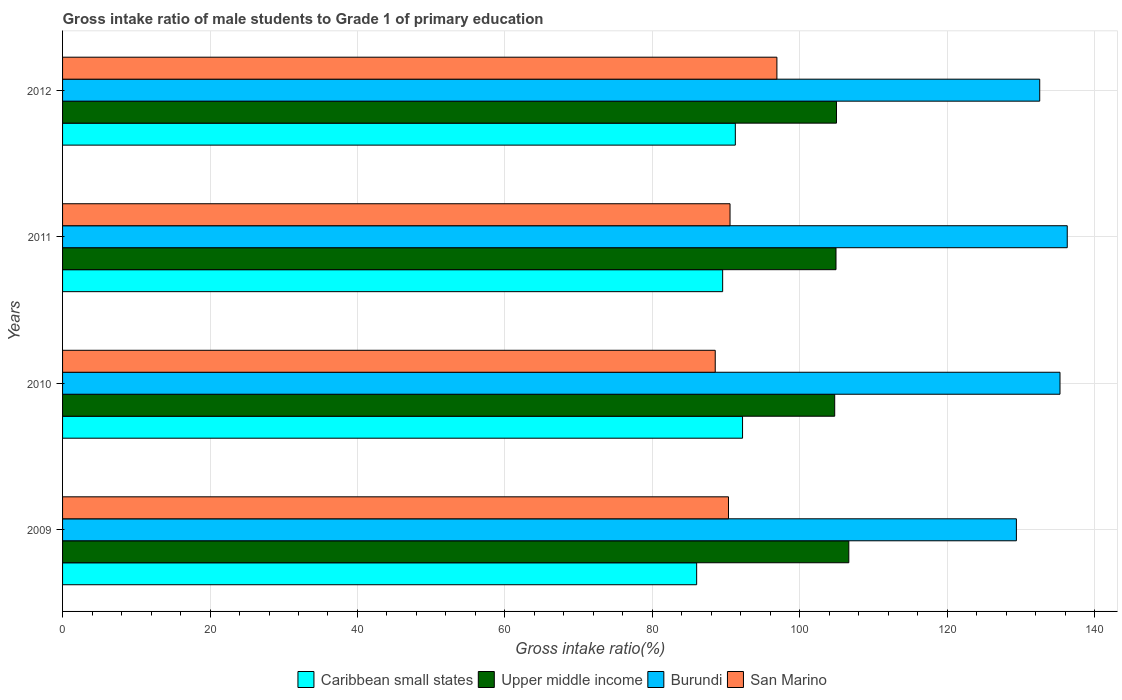Are the number of bars on each tick of the Y-axis equal?
Your response must be concise. Yes. How many bars are there on the 1st tick from the top?
Your answer should be compact. 4. What is the label of the 3rd group of bars from the top?
Offer a terse response. 2010. In how many cases, is the number of bars for a given year not equal to the number of legend labels?
Provide a short and direct response. 0. What is the gross intake ratio in San Marino in 2011?
Your answer should be very brief. 90.53. Across all years, what is the maximum gross intake ratio in San Marino?
Ensure brevity in your answer.  96.89. Across all years, what is the minimum gross intake ratio in San Marino?
Your answer should be very brief. 88.52. In which year was the gross intake ratio in Burundi maximum?
Provide a succinct answer. 2011. What is the total gross intake ratio in San Marino in the graph?
Offer a very short reply. 366.27. What is the difference between the gross intake ratio in San Marino in 2009 and that in 2011?
Ensure brevity in your answer.  -0.21. What is the difference between the gross intake ratio in San Marino in 2010 and the gross intake ratio in Caribbean small states in 2009?
Your response must be concise. 2.52. What is the average gross intake ratio in Burundi per year?
Provide a succinct answer. 133.37. In the year 2010, what is the difference between the gross intake ratio in San Marino and gross intake ratio in Caribbean small states?
Offer a very short reply. -3.71. What is the ratio of the gross intake ratio in Upper middle income in 2010 to that in 2011?
Your answer should be very brief. 1. Is the difference between the gross intake ratio in San Marino in 2011 and 2012 greater than the difference between the gross intake ratio in Caribbean small states in 2011 and 2012?
Make the answer very short. No. What is the difference between the highest and the second highest gross intake ratio in Upper middle income?
Keep it short and to the point. 1.67. What is the difference between the highest and the lowest gross intake ratio in Caribbean small states?
Keep it short and to the point. 6.23. In how many years, is the gross intake ratio in Upper middle income greater than the average gross intake ratio in Upper middle income taken over all years?
Provide a succinct answer. 1. Is the sum of the gross intake ratio in Upper middle income in 2010 and 2011 greater than the maximum gross intake ratio in San Marino across all years?
Make the answer very short. Yes. What does the 3rd bar from the top in 2012 represents?
Ensure brevity in your answer.  Upper middle income. What does the 1st bar from the bottom in 2011 represents?
Offer a very short reply. Caribbean small states. How many years are there in the graph?
Provide a short and direct response. 4. Where does the legend appear in the graph?
Make the answer very short. Bottom center. How are the legend labels stacked?
Offer a terse response. Horizontal. What is the title of the graph?
Your answer should be compact. Gross intake ratio of male students to Grade 1 of primary education. What is the label or title of the X-axis?
Your response must be concise. Gross intake ratio(%). What is the Gross intake ratio(%) of Caribbean small states in 2009?
Provide a short and direct response. 86. What is the Gross intake ratio(%) in Upper middle income in 2009?
Make the answer very short. 106.64. What is the Gross intake ratio(%) in Burundi in 2009?
Offer a terse response. 129.37. What is the Gross intake ratio(%) in San Marino in 2009?
Provide a short and direct response. 90.32. What is the Gross intake ratio(%) in Caribbean small states in 2010?
Provide a short and direct response. 92.23. What is the Gross intake ratio(%) of Upper middle income in 2010?
Make the answer very short. 104.73. What is the Gross intake ratio(%) of Burundi in 2010?
Ensure brevity in your answer.  135.29. What is the Gross intake ratio(%) in San Marino in 2010?
Ensure brevity in your answer.  88.52. What is the Gross intake ratio(%) in Caribbean small states in 2011?
Offer a very short reply. 89.53. What is the Gross intake ratio(%) in Upper middle income in 2011?
Your answer should be very brief. 104.91. What is the Gross intake ratio(%) of Burundi in 2011?
Keep it short and to the point. 136.27. What is the Gross intake ratio(%) in San Marino in 2011?
Provide a short and direct response. 90.53. What is the Gross intake ratio(%) of Caribbean small states in 2012?
Your answer should be compact. 91.25. What is the Gross intake ratio(%) in Upper middle income in 2012?
Keep it short and to the point. 104.97. What is the Gross intake ratio(%) in Burundi in 2012?
Your answer should be very brief. 132.54. What is the Gross intake ratio(%) in San Marino in 2012?
Offer a terse response. 96.89. Across all years, what is the maximum Gross intake ratio(%) of Caribbean small states?
Provide a succinct answer. 92.23. Across all years, what is the maximum Gross intake ratio(%) in Upper middle income?
Your answer should be very brief. 106.64. Across all years, what is the maximum Gross intake ratio(%) in Burundi?
Your answer should be compact. 136.27. Across all years, what is the maximum Gross intake ratio(%) of San Marino?
Your answer should be compact. 96.89. Across all years, what is the minimum Gross intake ratio(%) of Caribbean small states?
Keep it short and to the point. 86. Across all years, what is the minimum Gross intake ratio(%) of Upper middle income?
Offer a terse response. 104.73. Across all years, what is the minimum Gross intake ratio(%) in Burundi?
Ensure brevity in your answer.  129.37. Across all years, what is the minimum Gross intake ratio(%) in San Marino?
Keep it short and to the point. 88.52. What is the total Gross intake ratio(%) of Caribbean small states in the graph?
Offer a terse response. 359.02. What is the total Gross intake ratio(%) of Upper middle income in the graph?
Offer a very short reply. 421.25. What is the total Gross intake ratio(%) of Burundi in the graph?
Provide a succinct answer. 533.47. What is the total Gross intake ratio(%) of San Marino in the graph?
Keep it short and to the point. 366.27. What is the difference between the Gross intake ratio(%) of Caribbean small states in 2009 and that in 2010?
Provide a succinct answer. -6.23. What is the difference between the Gross intake ratio(%) of Upper middle income in 2009 and that in 2010?
Provide a succinct answer. 1.92. What is the difference between the Gross intake ratio(%) in Burundi in 2009 and that in 2010?
Offer a very short reply. -5.92. What is the difference between the Gross intake ratio(%) of San Marino in 2009 and that in 2010?
Keep it short and to the point. 1.8. What is the difference between the Gross intake ratio(%) in Caribbean small states in 2009 and that in 2011?
Keep it short and to the point. -3.53. What is the difference between the Gross intake ratio(%) of Upper middle income in 2009 and that in 2011?
Your answer should be compact. 1.74. What is the difference between the Gross intake ratio(%) of Burundi in 2009 and that in 2011?
Your answer should be compact. -6.9. What is the difference between the Gross intake ratio(%) of San Marino in 2009 and that in 2011?
Your response must be concise. -0.21. What is the difference between the Gross intake ratio(%) in Caribbean small states in 2009 and that in 2012?
Make the answer very short. -5.25. What is the difference between the Gross intake ratio(%) in Upper middle income in 2009 and that in 2012?
Make the answer very short. 1.67. What is the difference between the Gross intake ratio(%) in Burundi in 2009 and that in 2012?
Your answer should be compact. -3.16. What is the difference between the Gross intake ratio(%) in San Marino in 2009 and that in 2012?
Give a very brief answer. -6.57. What is the difference between the Gross intake ratio(%) of Caribbean small states in 2010 and that in 2011?
Offer a terse response. 2.7. What is the difference between the Gross intake ratio(%) in Upper middle income in 2010 and that in 2011?
Provide a succinct answer. -0.18. What is the difference between the Gross intake ratio(%) in Burundi in 2010 and that in 2011?
Give a very brief answer. -0.98. What is the difference between the Gross intake ratio(%) of San Marino in 2010 and that in 2011?
Your answer should be very brief. -2.01. What is the difference between the Gross intake ratio(%) in Caribbean small states in 2010 and that in 2012?
Offer a terse response. 0.98. What is the difference between the Gross intake ratio(%) of Upper middle income in 2010 and that in 2012?
Give a very brief answer. -0.24. What is the difference between the Gross intake ratio(%) in Burundi in 2010 and that in 2012?
Provide a succinct answer. 2.75. What is the difference between the Gross intake ratio(%) of San Marino in 2010 and that in 2012?
Ensure brevity in your answer.  -8.37. What is the difference between the Gross intake ratio(%) of Caribbean small states in 2011 and that in 2012?
Your answer should be compact. -1.72. What is the difference between the Gross intake ratio(%) in Upper middle income in 2011 and that in 2012?
Your response must be concise. -0.07. What is the difference between the Gross intake ratio(%) in Burundi in 2011 and that in 2012?
Give a very brief answer. 3.74. What is the difference between the Gross intake ratio(%) of San Marino in 2011 and that in 2012?
Offer a terse response. -6.36. What is the difference between the Gross intake ratio(%) of Caribbean small states in 2009 and the Gross intake ratio(%) of Upper middle income in 2010?
Provide a short and direct response. -18.72. What is the difference between the Gross intake ratio(%) in Caribbean small states in 2009 and the Gross intake ratio(%) in Burundi in 2010?
Provide a short and direct response. -49.28. What is the difference between the Gross intake ratio(%) of Caribbean small states in 2009 and the Gross intake ratio(%) of San Marino in 2010?
Your answer should be compact. -2.52. What is the difference between the Gross intake ratio(%) of Upper middle income in 2009 and the Gross intake ratio(%) of Burundi in 2010?
Your answer should be very brief. -28.64. What is the difference between the Gross intake ratio(%) of Upper middle income in 2009 and the Gross intake ratio(%) of San Marino in 2010?
Offer a terse response. 18.12. What is the difference between the Gross intake ratio(%) of Burundi in 2009 and the Gross intake ratio(%) of San Marino in 2010?
Make the answer very short. 40.85. What is the difference between the Gross intake ratio(%) in Caribbean small states in 2009 and the Gross intake ratio(%) in Upper middle income in 2011?
Offer a very short reply. -18.9. What is the difference between the Gross intake ratio(%) of Caribbean small states in 2009 and the Gross intake ratio(%) of Burundi in 2011?
Your response must be concise. -50.27. What is the difference between the Gross intake ratio(%) in Caribbean small states in 2009 and the Gross intake ratio(%) in San Marino in 2011?
Your response must be concise. -4.53. What is the difference between the Gross intake ratio(%) in Upper middle income in 2009 and the Gross intake ratio(%) in Burundi in 2011?
Provide a succinct answer. -29.63. What is the difference between the Gross intake ratio(%) of Upper middle income in 2009 and the Gross intake ratio(%) of San Marino in 2011?
Your response must be concise. 16.11. What is the difference between the Gross intake ratio(%) of Burundi in 2009 and the Gross intake ratio(%) of San Marino in 2011?
Your response must be concise. 38.84. What is the difference between the Gross intake ratio(%) in Caribbean small states in 2009 and the Gross intake ratio(%) in Upper middle income in 2012?
Provide a succinct answer. -18.97. What is the difference between the Gross intake ratio(%) in Caribbean small states in 2009 and the Gross intake ratio(%) in Burundi in 2012?
Your answer should be compact. -46.53. What is the difference between the Gross intake ratio(%) of Caribbean small states in 2009 and the Gross intake ratio(%) of San Marino in 2012?
Provide a succinct answer. -10.89. What is the difference between the Gross intake ratio(%) in Upper middle income in 2009 and the Gross intake ratio(%) in Burundi in 2012?
Your answer should be compact. -25.89. What is the difference between the Gross intake ratio(%) in Upper middle income in 2009 and the Gross intake ratio(%) in San Marino in 2012?
Offer a very short reply. 9.75. What is the difference between the Gross intake ratio(%) in Burundi in 2009 and the Gross intake ratio(%) in San Marino in 2012?
Your response must be concise. 32.48. What is the difference between the Gross intake ratio(%) in Caribbean small states in 2010 and the Gross intake ratio(%) in Upper middle income in 2011?
Keep it short and to the point. -12.68. What is the difference between the Gross intake ratio(%) of Caribbean small states in 2010 and the Gross intake ratio(%) of Burundi in 2011?
Your answer should be compact. -44.04. What is the difference between the Gross intake ratio(%) in Caribbean small states in 2010 and the Gross intake ratio(%) in San Marino in 2011?
Keep it short and to the point. 1.7. What is the difference between the Gross intake ratio(%) in Upper middle income in 2010 and the Gross intake ratio(%) in Burundi in 2011?
Provide a short and direct response. -31.54. What is the difference between the Gross intake ratio(%) of Upper middle income in 2010 and the Gross intake ratio(%) of San Marino in 2011?
Your answer should be very brief. 14.2. What is the difference between the Gross intake ratio(%) of Burundi in 2010 and the Gross intake ratio(%) of San Marino in 2011?
Give a very brief answer. 44.76. What is the difference between the Gross intake ratio(%) of Caribbean small states in 2010 and the Gross intake ratio(%) of Upper middle income in 2012?
Provide a short and direct response. -12.74. What is the difference between the Gross intake ratio(%) of Caribbean small states in 2010 and the Gross intake ratio(%) of Burundi in 2012?
Offer a very short reply. -40.31. What is the difference between the Gross intake ratio(%) in Caribbean small states in 2010 and the Gross intake ratio(%) in San Marino in 2012?
Provide a succinct answer. -4.66. What is the difference between the Gross intake ratio(%) of Upper middle income in 2010 and the Gross intake ratio(%) of Burundi in 2012?
Your response must be concise. -27.81. What is the difference between the Gross intake ratio(%) of Upper middle income in 2010 and the Gross intake ratio(%) of San Marino in 2012?
Offer a very short reply. 7.84. What is the difference between the Gross intake ratio(%) in Burundi in 2010 and the Gross intake ratio(%) in San Marino in 2012?
Give a very brief answer. 38.4. What is the difference between the Gross intake ratio(%) of Caribbean small states in 2011 and the Gross intake ratio(%) of Upper middle income in 2012?
Provide a succinct answer. -15.44. What is the difference between the Gross intake ratio(%) of Caribbean small states in 2011 and the Gross intake ratio(%) of Burundi in 2012?
Offer a very short reply. -43.01. What is the difference between the Gross intake ratio(%) in Caribbean small states in 2011 and the Gross intake ratio(%) in San Marino in 2012?
Offer a terse response. -7.36. What is the difference between the Gross intake ratio(%) of Upper middle income in 2011 and the Gross intake ratio(%) of Burundi in 2012?
Make the answer very short. -27.63. What is the difference between the Gross intake ratio(%) in Upper middle income in 2011 and the Gross intake ratio(%) in San Marino in 2012?
Ensure brevity in your answer.  8.01. What is the difference between the Gross intake ratio(%) in Burundi in 2011 and the Gross intake ratio(%) in San Marino in 2012?
Make the answer very short. 39.38. What is the average Gross intake ratio(%) of Caribbean small states per year?
Give a very brief answer. 89.75. What is the average Gross intake ratio(%) of Upper middle income per year?
Provide a succinct answer. 105.31. What is the average Gross intake ratio(%) in Burundi per year?
Ensure brevity in your answer.  133.37. What is the average Gross intake ratio(%) of San Marino per year?
Provide a short and direct response. 91.57. In the year 2009, what is the difference between the Gross intake ratio(%) of Caribbean small states and Gross intake ratio(%) of Upper middle income?
Give a very brief answer. -20.64. In the year 2009, what is the difference between the Gross intake ratio(%) of Caribbean small states and Gross intake ratio(%) of Burundi?
Provide a short and direct response. -43.37. In the year 2009, what is the difference between the Gross intake ratio(%) of Caribbean small states and Gross intake ratio(%) of San Marino?
Offer a terse response. -4.32. In the year 2009, what is the difference between the Gross intake ratio(%) of Upper middle income and Gross intake ratio(%) of Burundi?
Your answer should be very brief. -22.73. In the year 2009, what is the difference between the Gross intake ratio(%) in Upper middle income and Gross intake ratio(%) in San Marino?
Keep it short and to the point. 16.32. In the year 2009, what is the difference between the Gross intake ratio(%) in Burundi and Gross intake ratio(%) in San Marino?
Keep it short and to the point. 39.05. In the year 2010, what is the difference between the Gross intake ratio(%) in Caribbean small states and Gross intake ratio(%) in Upper middle income?
Your response must be concise. -12.5. In the year 2010, what is the difference between the Gross intake ratio(%) in Caribbean small states and Gross intake ratio(%) in Burundi?
Provide a succinct answer. -43.06. In the year 2010, what is the difference between the Gross intake ratio(%) of Caribbean small states and Gross intake ratio(%) of San Marino?
Your response must be concise. 3.71. In the year 2010, what is the difference between the Gross intake ratio(%) of Upper middle income and Gross intake ratio(%) of Burundi?
Your response must be concise. -30.56. In the year 2010, what is the difference between the Gross intake ratio(%) in Upper middle income and Gross intake ratio(%) in San Marino?
Keep it short and to the point. 16.2. In the year 2010, what is the difference between the Gross intake ratio(%) in Burundi and Gross intake ratio(%) in San Marino?
Provide a short and direct response. 46.76. In the year 2011, what is the difference between the Gross intake ratio(%) in Caribbean small states and Gross intake ratio(%) in Upper middle income?
Make the answer very short. -15.37. In the year 2011, what is the difference between the Gross intake ratio(%) of Caribbean small states and Gross intake ratio(%) of Burundi?
Your answer should be compact. -46.74. In the year 2011, what is the difference between the Gross intake ratio(%) of Caribbean small states and Gross intake ratio(%) of San Marino?
Make the answer very short. -1. In the year 2011, what is the difference between the Gross intake ratio(%) of Upper middle income and Gross intake ratio(%) of Burundi?
Offer a terse response. -31.37. In the year 2011, what is the difference between the Gross intake ratio(%) of Upper middle income and Gross intake ratio(%) of San Marino?
Keep it short and to the point. 14.37. In the year 2011, what is the difference between the Gross intake ratio(%) of Burundi and Gross intake ratio(%) of San Marino?
Make the answer very short. 45.74. In the year 2012, what is the difference between the Gross intake ratio(%) of Caribbean small states and Gross intake ratio(%) of Upper middle income?
Provide a short and direct response. -13.72. In the year 2012, what is the difference between the Gross intake ratio(%) of Caribbean small states and Gross intake ratio(%) of Burundi?
Provide a short and direct response. -41.29. In the year 2012, what is the difference between the Gross intake ratio(%) in Caribbean small states and Gross intake ratio(%) in San Marino?
Offer a very short reply. -5.64. In the year 2012, what is the difference between the Gross intake ratio(%) of Upper middle income and Gross intake ratio(%) of Burundi?
Your response must be concise. -27.57. In the year 2012, what is the difference between the Gross intake ratio(%) in Upper middle income and Gross intake ratio(%) in San Marino?
Offer a terse response. 8.08. In the year 2012, what is the difference between the Gross intake ratio(%) of Burundi and Gross intake ratio(%) of San Marino?
Make the answer very short. 35.65. What is the ratio of the Gross intake ratio(%) of Caribbean small states in 2009 to that in 2010?
Provide a short and direct response. 0.93. What is the ratio of the Gross intake ratio(%) of Upper middle income in 2009 to that in 2010?
Your response must be concise. 1.02. What is the ratio of the Gross intake ratio(%) in Burundi in 2009 to that in 2010?
Provide a short and direct response. 0.96. What is the ratio of the Gross intake ratio(%) of San Marino in 2009 to that in 2010?
Give a very brief answer. 1.02. What is the ratio of the Gross intake ratio(%) of Caribbean small states in 2009 to that in 2011?
Your answer should be compact. 0.96. What is the ratio of the Gross intake ratio(%) in Upper middle income in 2009 to that in 2011?
Keep it short and to the point. 1.02. What is the ratio of the Gross intake ratio(%) of Burundi in 2009 to that in 2011?
Make the answer very short. 0.95. What is the ratio of the Gross intake ratio(%) of Caribbean small states in 2009 to that in 2012?
Your answer should be compact. 0.94. What is the ratio of the Gross intake ratio(%) in Upper middle income in 2009 to that in 2012?
Give a very brief answer. 1.02. What is the ratio of the Gross intake ratio(%) of Burundi in 2009 to that in 2012?
Offer a terse response. 0.98. What is the ratio of the Gross intake ratio(%) of San Marino in 2009 to that in 2012?
Your answer should be very brief. 0.93. What is the ratio of the Gross intake ratio(%) in Caribbean small states in 2010 to that in 2011?
Give a very brief answer. 1.03. What is the ratio of the Gross intake ratio(%) of San Marino in 2010 to that in 2011?
Your answer should be compact. 0.98. What is the ratio of the Gross intake ratio(%) of Caribbean small states in 2010 to that in 2012?
Provide a succinct answer. 1.01. What is the ratio of the Gross intake ratio(%) in Burundi in 2010 to that in 2012?
Your answer should be compact. 1.02. What is the ratio of the Gross intake ratio(%) of San Marino in 2010 to that in 2012?
Keep it short and to the point. 0.91. What is the ratio of the Gross intake ratio(%) of Caribbean small states in 2011 to that in 2012?
Your answer should be compact. 0.98. What is the ratio of the Gross intake ratio(%) in Upper middle income in 2011 to that in 2012?
Provide a succinct answer. 1. What is the ratio of the Gross intake ratio(%) of Burundi in 2011 to that in 2012?
Ensure brevity in your answer.  1.03. What is the ratio of the Gross intake ratio(%) of San Marino in 2011 to that in 2012?
Your response must be concise. 0.93. What is the difference between the highest and the second highest Gross intake ratio(%) in Caribbean small states?
Provide a short and direct response. 0.98. What is the difference between the highest and the second highest Gross intake ratio(%) in Upper middle income?
Give a very brief answer. 1.67. What is the difference between the highest and the second highest Gross intake ratio(%) of Burundi?
Your answer should be compact. 0.98. What is the difference between the highest and the second highest Gross intake ratio(%) of San Marino?
Give a very brief answer. 6.36. What is the difference between the highest and the lowest Gross intake ratio(%) in Caribbean small states?
Offer a terse response. 6.23. What is the difference between the highest and the lowest Gross intake ratio(%) of Upper middle income?
Provide a succinct answer. 1.92. What is the difference between the highest and the lowest Gross intake ratio(%) of Burundi?
Your response must be concise. 6.9. What is the difference between the highest and the lowest Gross intake ratio(%) in San Marino?
Offer a very short reply. 8.37. 